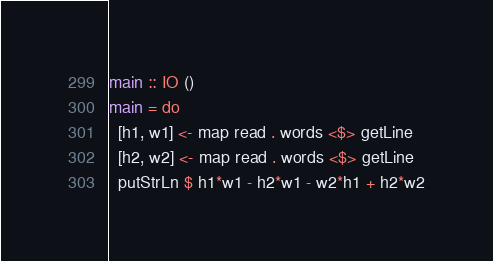Convert code to text. <code><loc_0><loc_0><loc_500><loc_500><_Haskell_>main :: IO ()
main = do
  [h1, w1] <- map read . words <$> getLine
  [h2, w2] <- map read . words <$> getLine
  putStrLn $ h1*w1 - h2*w1 - w2*h1 + h2*w2</code> 